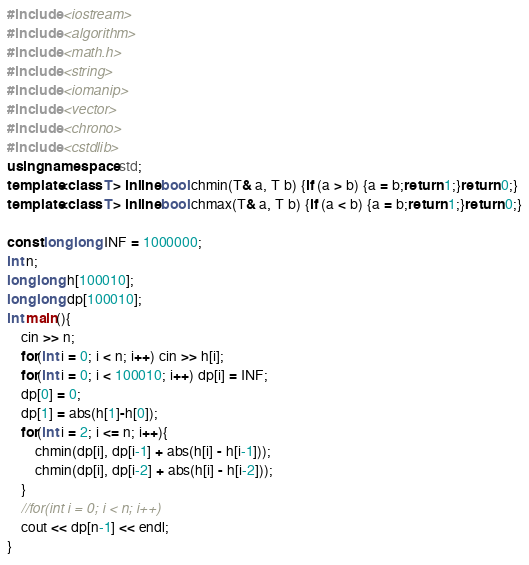Convert code to text. <code><loc_0><loc_0><loc_500><loc_500><_C++_>#include <iostream>
#include <algorithm>
#include <math.h> 
#include <string>
#include <iomanip>
#include <vector>
#include <chrono>
#include <cstdlib>
using namespace std;
template<class T> inline bool chmin(T& a, T b) {if (a > b) {a = b;return 1;}return 0;}
template<class T> inline bool chmax(T& a, T b) {if (a < b) {a = b;return 1;}return 0;}

const long long INF = 1000000;
int n;
long long h[100010];
long long dp[100010];
int main(){
    cin >> n;
    for(int i = 0; i < n; i++) cin >> h[i];
    for(int i = 0; i < 100010; i++) dp[i] = INF;
    dp[0] = 0;
    dp[1] = abs(h[1]-h[0]);
    for(int i = 2; i <= n; i++){
        chmin(dp[i], dp[i-1] + abs(h[i] - h[i-1]));
        chmin(dp[i], dp[i-2] + abs(h[i] - h[i-2]));
    }
    //for(int i = 0; i < n; i++)
    cout << dp[n-1] << endl;
}
</code> 